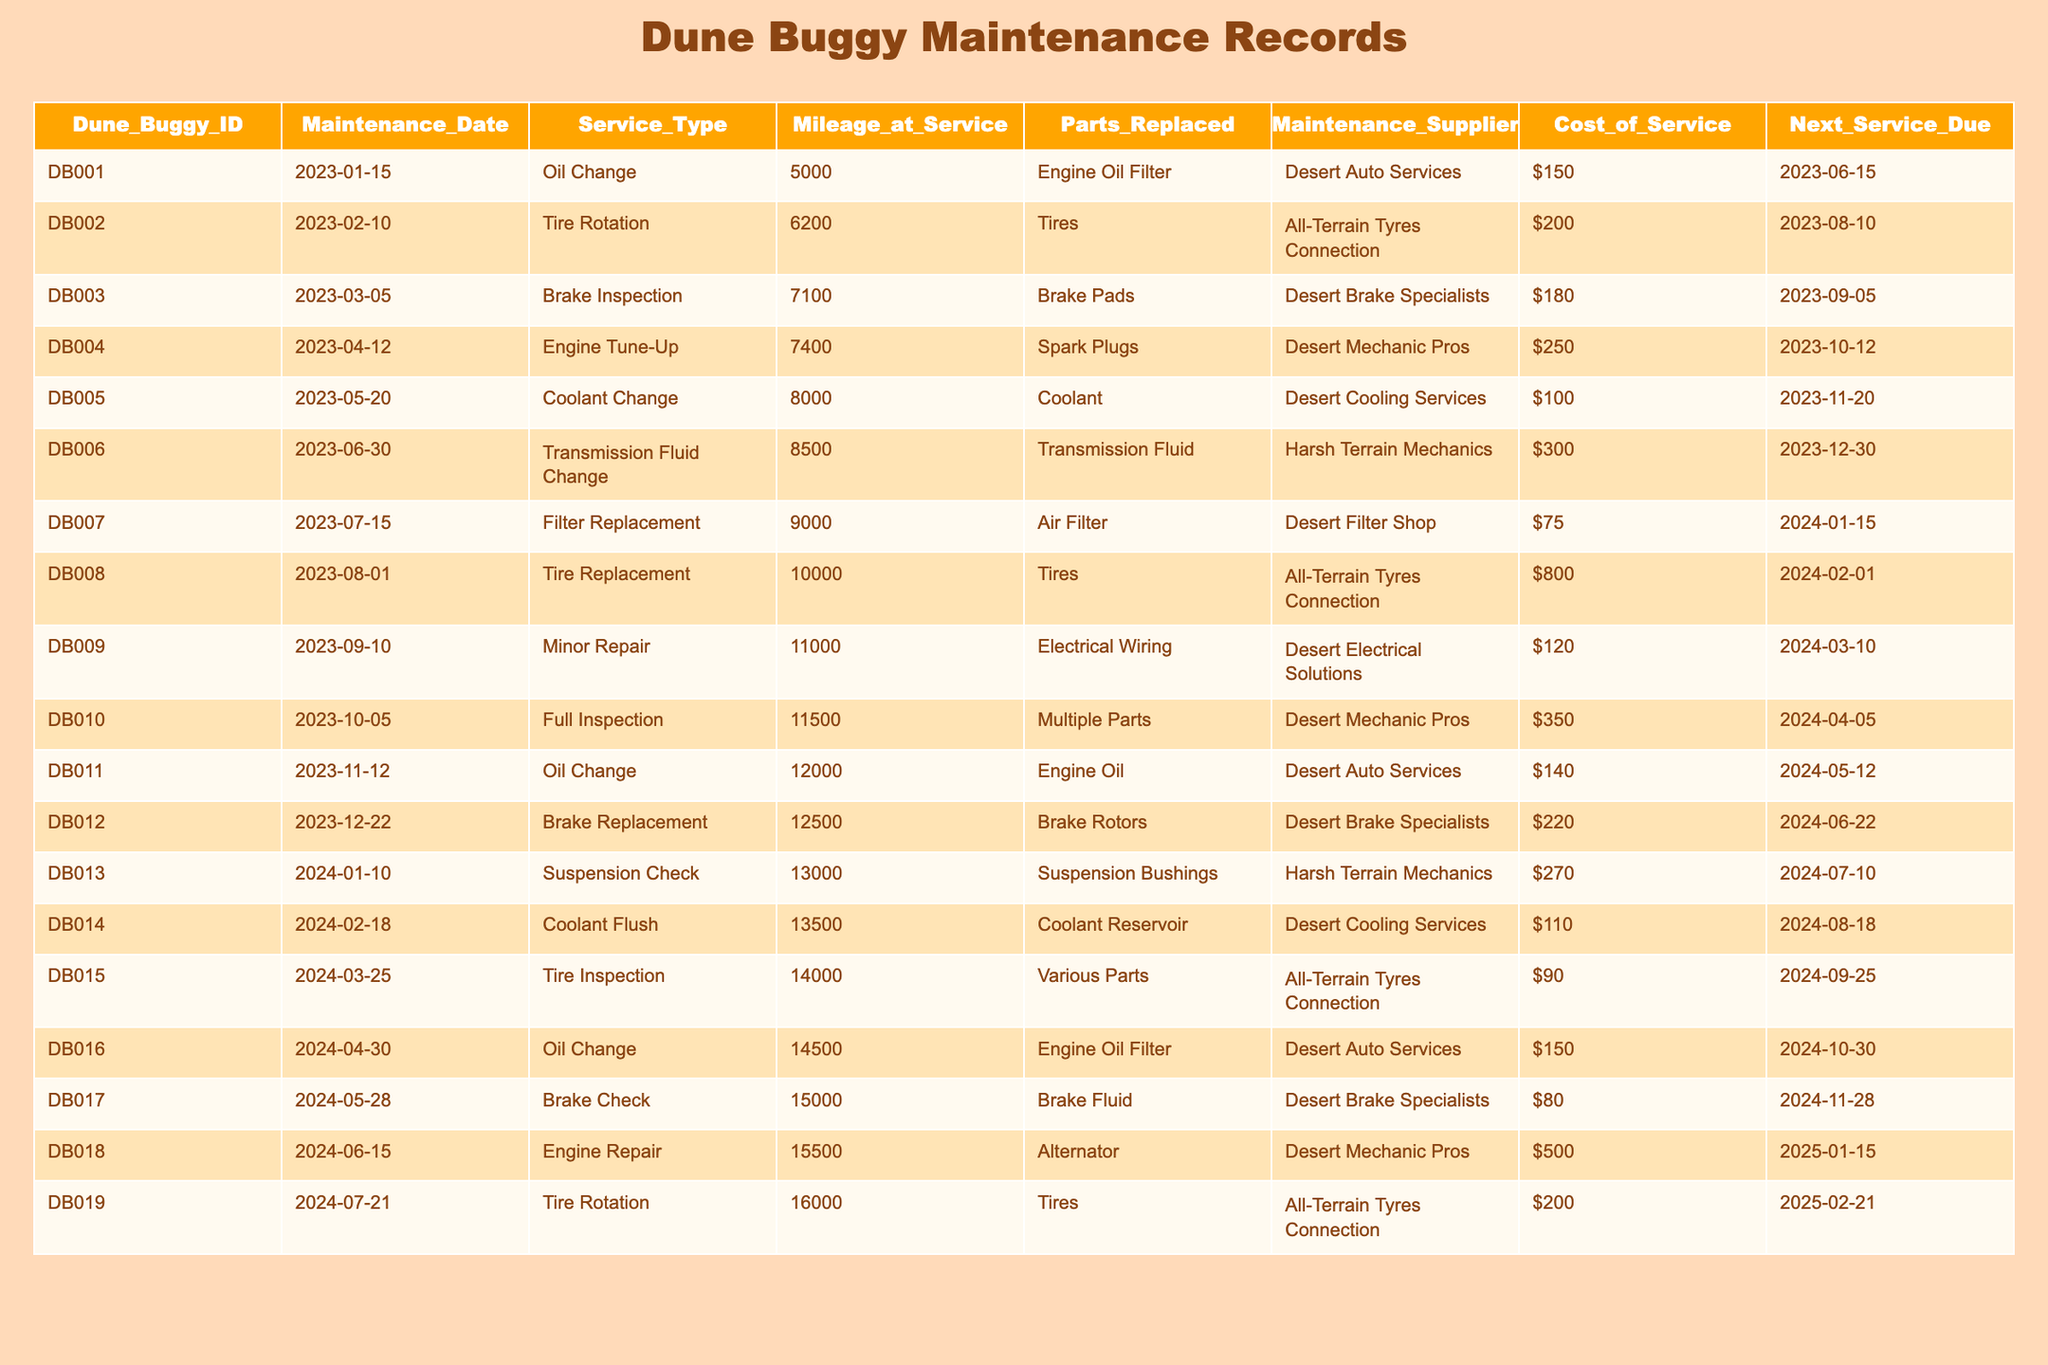What is the total cost of maintenance for Dune Buggy ID DB002? The maintenance cost for Dune Buggy ID DB002, according to the table, is directly listed as $200.
Answer: $200 When is the next service due for Dune Buggy ID DB010? The table states that the next service due for Dune Buggy ID DB010 is on 2024-04-05.
Answer: 2024-04-05 Which maintenance supplier performed the engine tune-up for Dune Buggy ID DB004? The supplier listed for the engine tune-up of Dune Buggy ID DB004 is Desert Mechanic Pros.
Answer: Desert Mechanic Pros What is the average cost of service for all dune buggies in the table? To find the average cost, sum the costs of all services: $150 + $200 + $180 + $250 + $100 + $300 + $75 + $800 + $120 + $350 + $140 + $220 + $270 + $110 + $90 + $150 + $80 + $500 + $200 = $3,650. There are 19 buggies, so the average cost is $3,650/19 ≈ $192.11.
Answer: Approximately $192.11 How many maintenance services have costs greater than $250? By reviewing the table, the services with costs greater than $250 are DB004 ($250), DB006 ($300), DB008 ($800), DB010 ($350), DB012 ($220), DB018 ($500). Only DB006, DB008, and DB010 exceed $250, totaling 4 services.
Answer: 4 services Is there a service type performed on Dune Buggy ID DB007? Yes, the service type for Dune Buggy ID DB007 is a Filter Replacement.
Answer: Yes What is the total mileage when the last service was performed on the dune buggies? The last service was performed on Dune Buggy ID DB019 at 16,000 miles. That is the highest mileage recorded for any service in the table.
Answer: 16,000 miles Which dune buggy had the highest maintenance cost recorded? By checking the costs listed, Dune Buggy ID DB008 had the highest cost of $800 for Tire Replacement.
Answer: DB008 How many different maintenance types are listed in the table? The distinct maintenance types are Oil Change, Tire Rotation, Brake Inspection, Engine Tune-Up, Coolant Change, Transmission Fluid Change, Filter Replacement, Tire Replacement, Minor Repair, Full Inspection, Brake Replacement, Suspension Check, Coolant Flush, Tire Inspection, and Brake Check, totaling 15 types.
Answer: 15 types Which Dune Buggy had an engine repair and what was the cost? Dune Buggy ID DB018 had an Engine Repair with a cost of $500.
Answer: DB018, $500 What was the cost difference between the tire replacement of DB008 and the minor repair of DB009? The cost of tire replacement for DB008 is $800 and the cost of minor repair for DB009 is $120. The difference is $800 - $120 = $680.
Answer: $680 